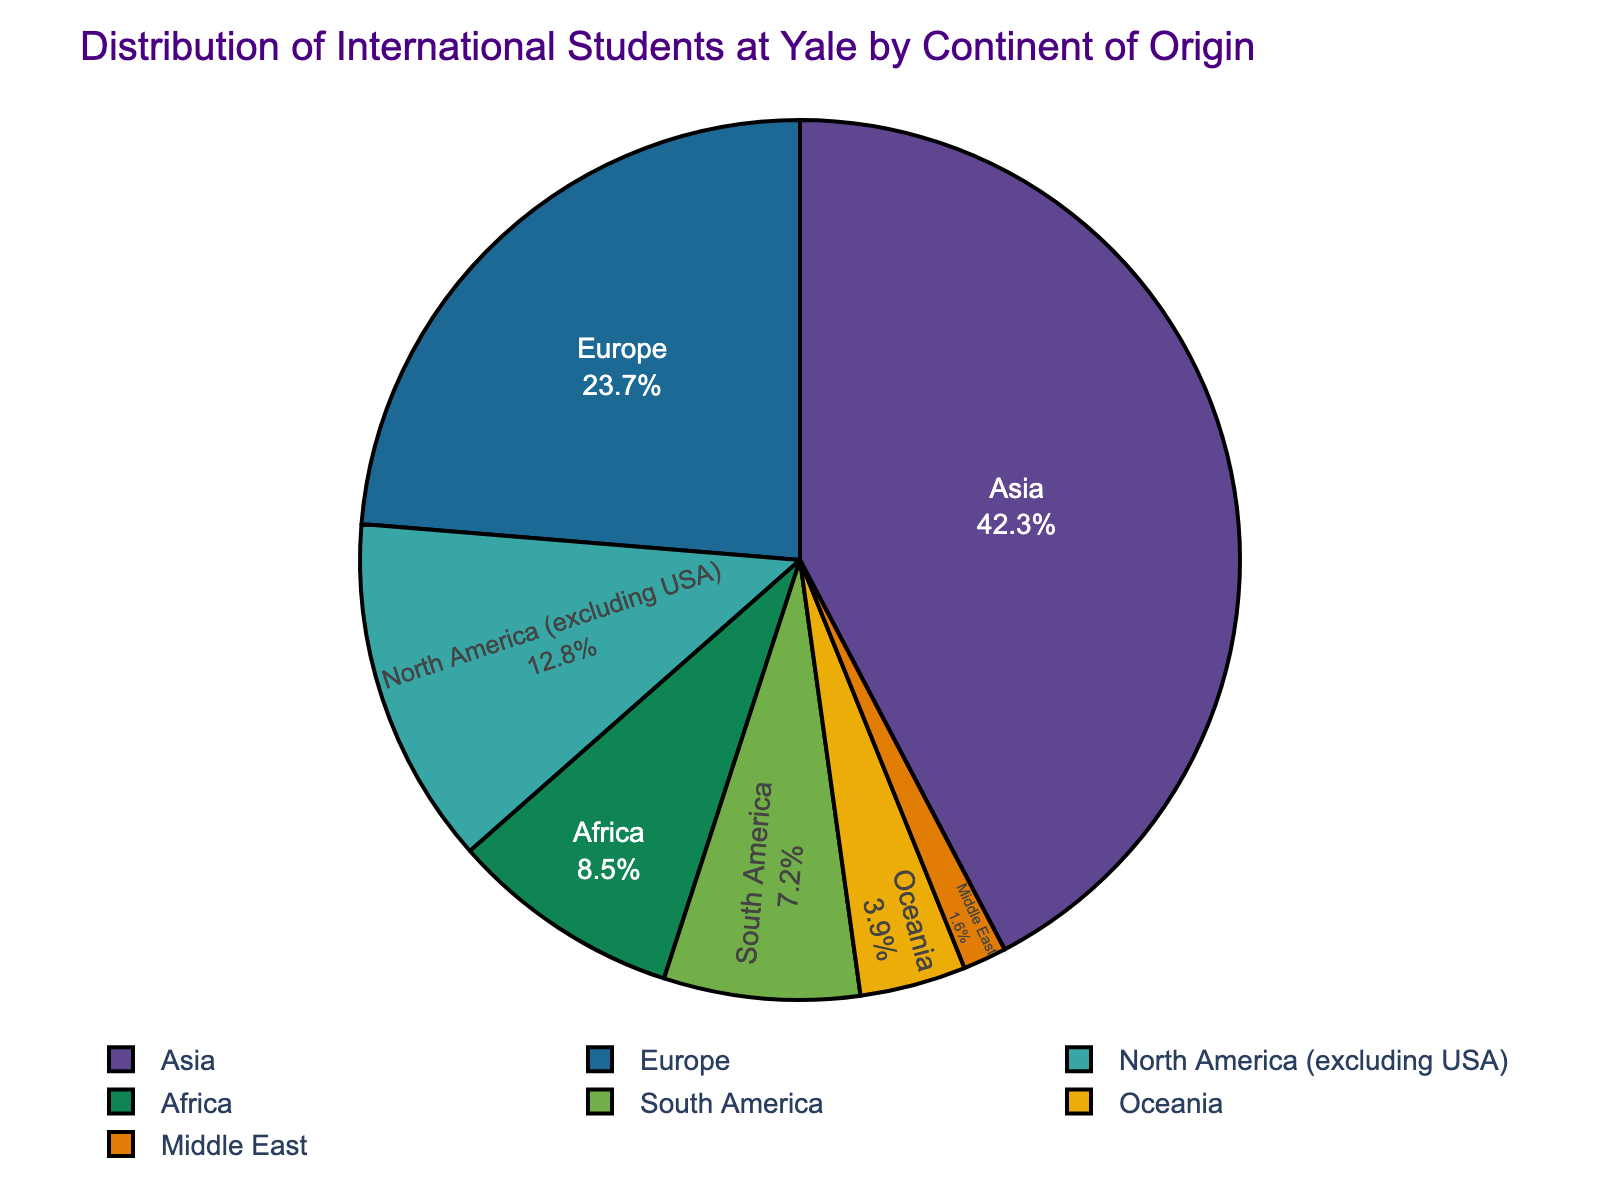What's the percentage of international students from Asia and Africa combined? To find the combined percentage, we add the percentages from Asia and Africa. Asia contributes 42.3% and Africa contributes 8.5%. Adding these together, 42.3 + 8.5 = 50.8%.
Answer: 50.8% Which continent has the second highest percentage of international students? By examining the pie chart, Asia is the highest at 42.3%, and the next largest slice is Europe at 23.7%.
Answer: Europe How much higher is the percentage of international students from Asia compared to South America? The percentage of international students from Asia is 42.3%, while South America contributes 7.2%. The difference is 42.3 - 7.2 = 35.1%.
Answer: 35.1% Which continents have less than 10% of international students each? By looking at the slices, continents that have less than 10% are Africa (8.5%), South America (7.2%), Oceania (3.9%), and Middle East (1.6%).
Answer: Africa, South America, Oceania, Middle East If the total number of international students is 1000, how many students come from North America (excluding USA)? If 12.8% of the students are from North America (excluding USA), then the number of students is 12.8% of 1000. This equals 0.128 * 1000 = 128 students.
Answer: 128 What is the total percentage of international students from continents other than Asia, Europe, and North America (excluding USA)? To find the total percentage from continents other than Asia, Europe, and North America (excluding USA), we add the percentages from Africa, South America, Oceania, and the Middle East. Summing these: 8.5 + 7.2 + 3.9 + 1.6 = 21.2%.
Answer: 21.2% Which is the smallest group by percentage, and what is its value? By observing the slices, the Middle East is the smallest group with 1.6%.
Answer: Middle East, 1.6% How many continents contribute more than 20% of the international students each? From the chart, Asia (42.3%) and Europe (23.7%) both contribute more than 20% each. There are 2 continents.
Answer: 2 What is the ratio of international students from Europe to those from Oceania? Europe has 23.7% and Oceania has 3.9%. The ratio is 23.7 / 3.9 = 6.08.
Answer: 6.08 What is the difference in percentage between the continent contributing the most and the least? Asia contributes the most at 42.3%, and the Middle East contributes the least at 1.6%. The difference is 42.3 - 1.6 = 40.7%.
Answer: 40.7% 